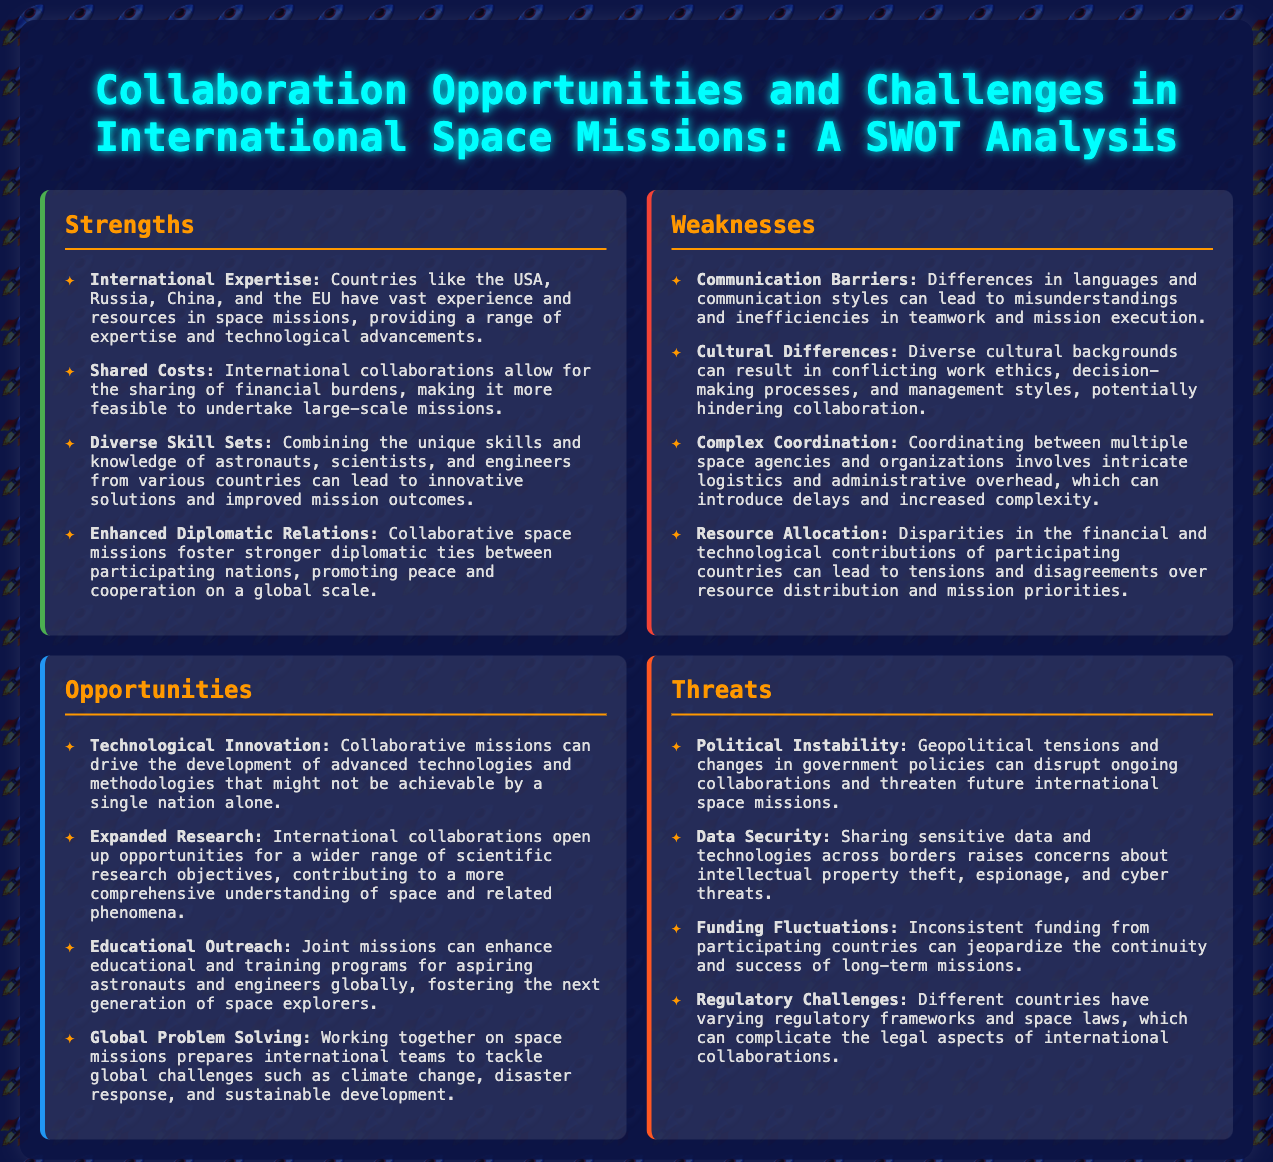What are the primary strengths mentioned? The strengths listed in the document include international expertise, shared costs, diverse skill sets, and enhanced diplomatic relations.
Answer: International expertise, shared costs, diverse skill sets, enhanced diplomatic relations How many weaknesses are identified? The document lists four specific weaknesses regarding collaboration in international space missions.
Answer: Four What is one opportunity mentioned for international collaborations? The document highlights technological innovation as a significant opportunity stemming from collaborative missions.
Answer: Technological innovation What is a key threat related to funding? Funding fluctuations are mentioned as a potential threat to the success of long-term missions.
Answer: Funding fluctuations What can international collaborations enhance in terms of education? The document states that joint missions can enhance educational and training programs for aspiring astronauts and engineers globally.
Answer: Educational outreach Which countries are noted for their expertise in space missions? The countries highlighted for their vast experience in space missions include the USA, Russia, China, and the EU.
Answer: USA, Russia, China, EU What is a potential challenge due to cultural diversity? Cultural differences can result in conflicting work ethics and management styles, as mentioned in the weaknesses.
Answer: Cultural differences What aspect of international space collaboration can improve global problem-solving? The document mentions that working together on space missions prepares international teams to tackle global challenges.
Answer: Global problem solving 